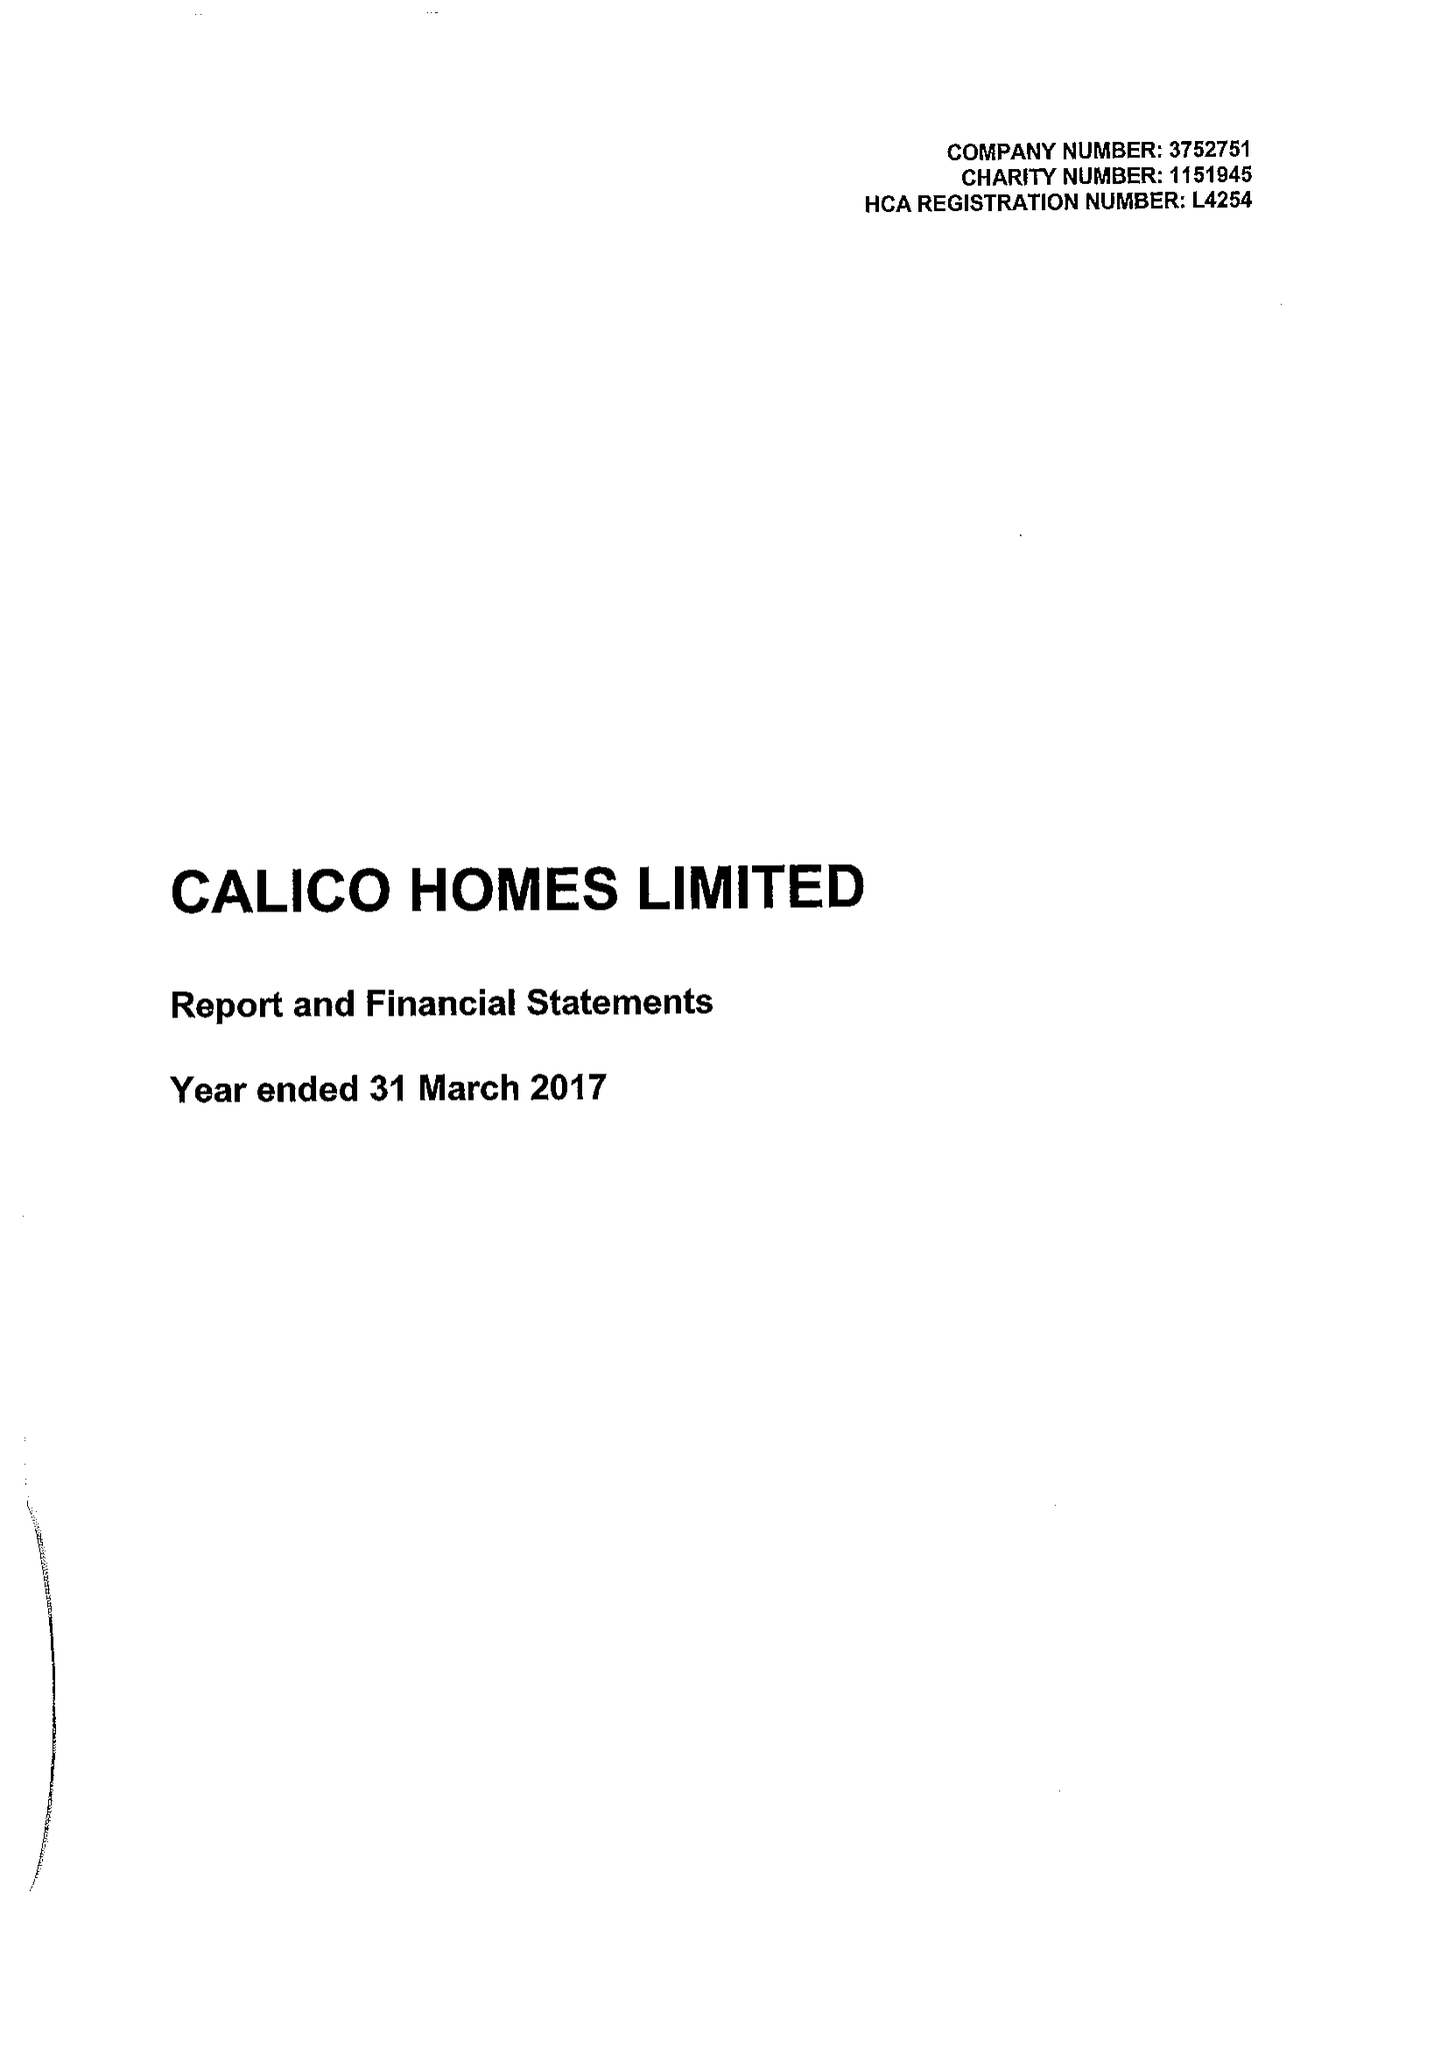What is the value for the charity_number?
Answer the question using a single word or phrase. 1151945 